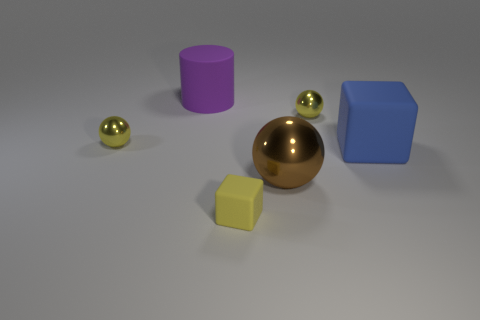The small rubber thing that is the same shape as the big blue thing is what color?
Offer a terse response. Yellow. There is a tiny sphere that is to the left of the cube that is in front of the large block; how many objects are right of it?
Keep it short and to the point. 5. Is there anything else that has the same material as the blue cube?
Make the answer very short. Yes. Are there fewer tiny shiny spheres to the right of the big purple matte object than shiny objects?
Provide a succinct answer. Yes. There is another matte object that is the same shape as the blue rubber thing; what size is it?
Make the answer very short. Small. How many spheres have the same material as the large purple object?
Offer a very short reply. 0. Is the yellow thing that is on the left side of the large purple rubber thing made of the same material as the cylinder?
Your answer should be compact. No. Are there the same number of blue objects that are to the left of the blue cube and small yellow shiny objects?
Make the answer very short. No. The blue matte thing is what size?
Offer a terse response. Large. How many matte objects have the same color as the big metal object?
Ensure brevity in your answer.  0. 